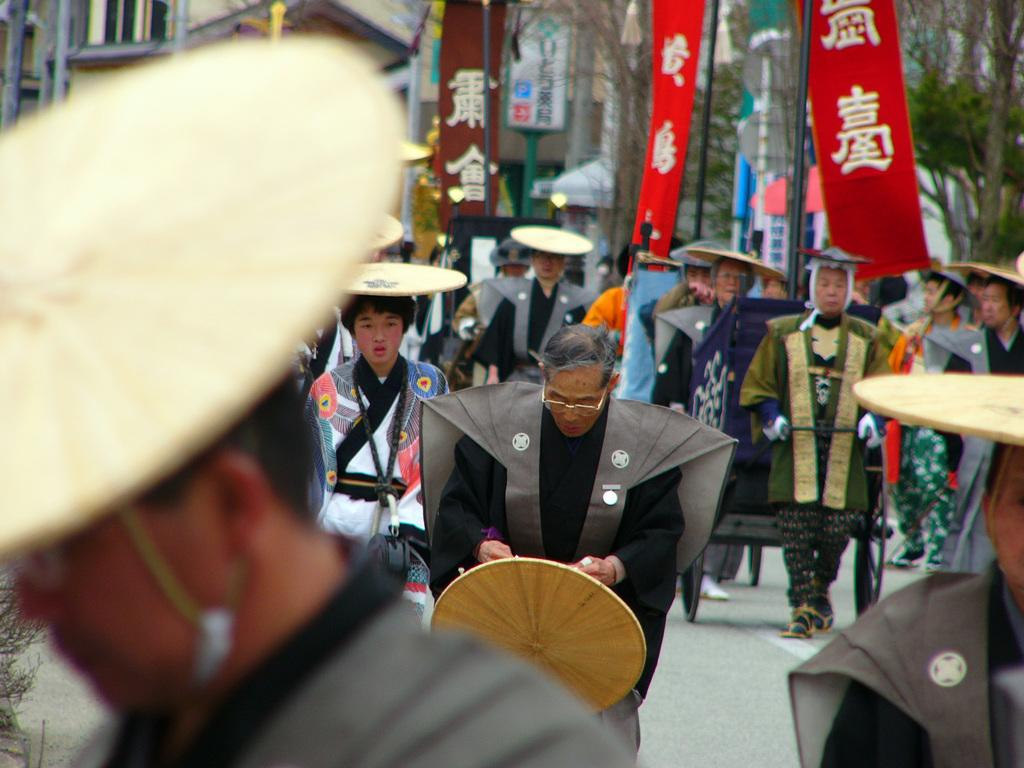How many people are in the image? There is a group of people in the image. What are the people wearing on their heads? The people are wearing hats. What is the person in the middle doing with their hat? One person in the middle is holding a hat in their hands. What can be seen in the background of the image? There are buildings and trees in the background of the image. What type of cork is being used to attack the person in the middle? There is no cork or attack present in the image; it features a group of people wearing hats and standing together. 